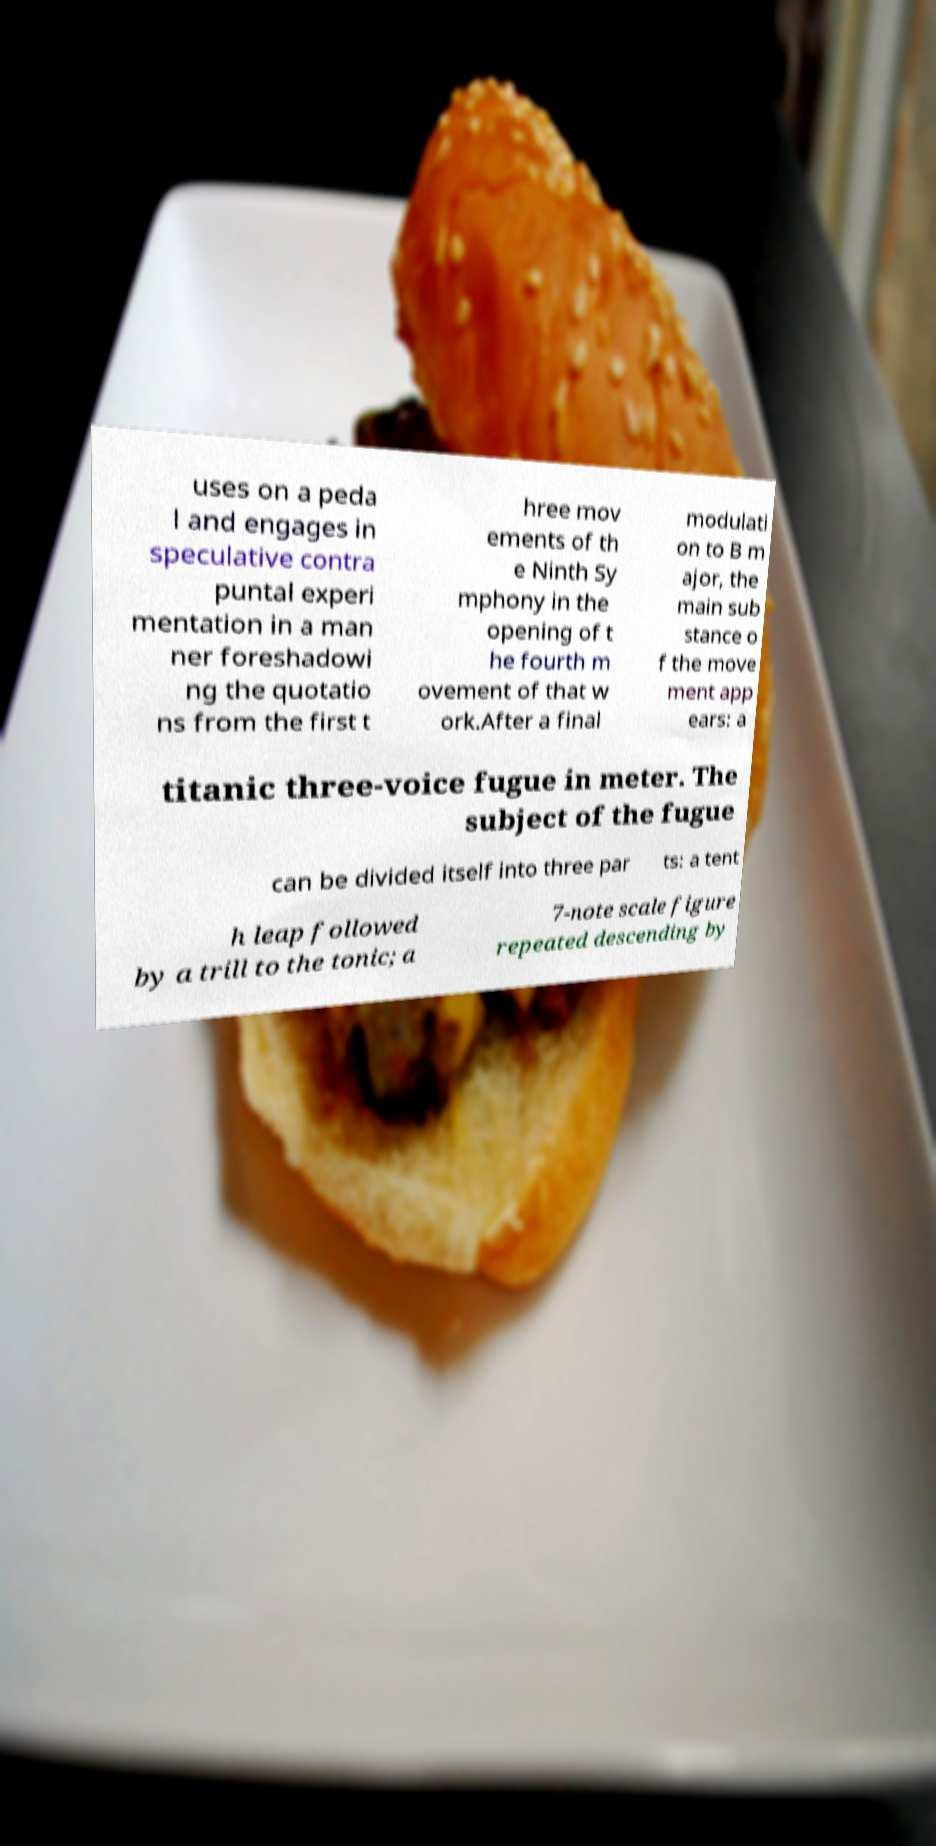Could you extract and type out the text from this image? uses on a peda l and engages in speculative contra puntal experi mentation in a man ner foreshadowi ng the quotatio ns from the first t hree mov ements of th e Ninth Sy mphony in the opening of t he fourth m ovement of that w ork.After a final modulati on to B m ajor, the main sub stance o f the move ment app ears: a titanic three-voice fugue in meter. The subject of the fugue can be divided itself into three par ts: a tent h leap followed by a trill to the tonic; a 7-note scale figure repeated descending by 